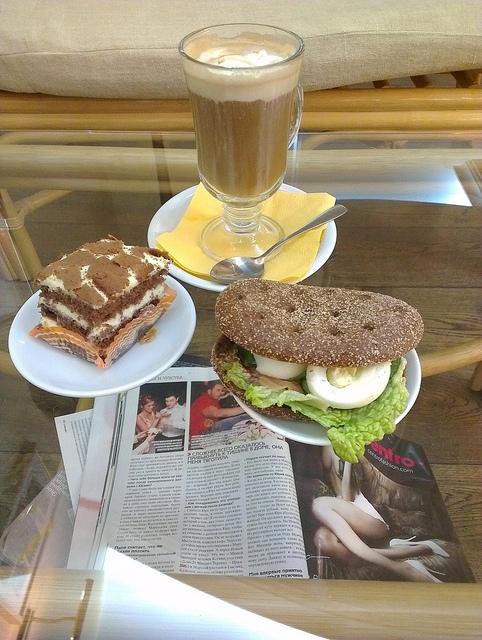Is there hot chocolate on the table?
Quick response, please. Yes. What is the table made of?
Answer briefly. Glass. Are there eggs on this sandwich?
Answer briefly. Yes. 